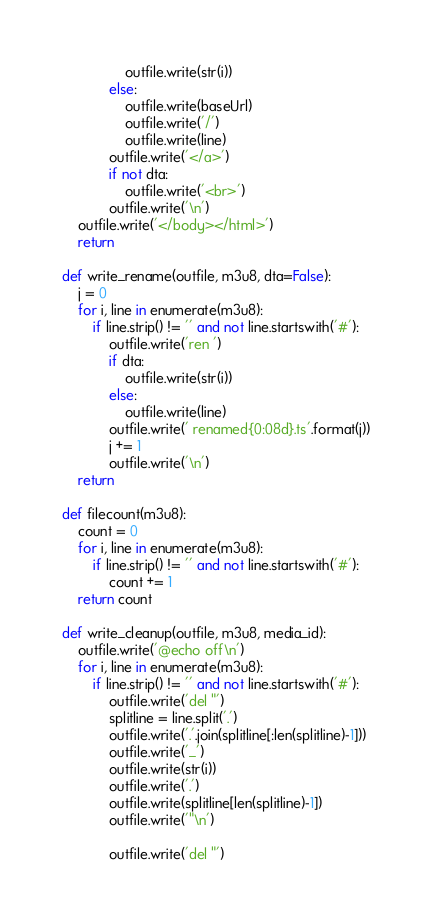<code> <loc_0><loc_0><loc_500><loc_500><_Python_>                outfile.write(str(i))
            else:
                outfile.write(baseUrl)
                outfile.write('/')
                outfile.write(line)
            outfile.write('</a>')
            if not dta:
                outfile.write('<br>')
            outfile.write('\n')
    outfile.write('</body></html>')
    return

def write_rename(outfile, m3u8, dta=False):
    j = 0
    for i, line in enumerate(m3u8):
        if line.strip() != '' and not line.startswith('#'):
            outfile.write('ren ')
            if dta:
                outfile.write(str(i))
            else:
                outfile.write(line)
            outfile.write(' renamed{0:08d}.ts'.format(j))
            j += 1
            outfile.write('\n')
    return

def filecount(m3u8):
    count = 0
    for i, line in enumerate(m3u8):
        if line.strip() != '' and not line.startswith('#'):
            count += 1
    return count

def write_cleanup(outfile, m3u8, media_id):
    outfile.write('@echo off\n')
    for i, line in enumerate(m3u8):
        if line.strip() != '' and not line.startswith('#'):
            outfile.write('del "')
            splitline = line.split('.')
            outfile.write('.'.join(splitline[:len(splitline)-1]))
            outfile.write('_')
            outfile.write(str(i))
            outfile.write('.')
            outfile.write(splitline[len(splitline)-1])
            outfile.write('"\n')
            
            outfile.write('del "')</code> 